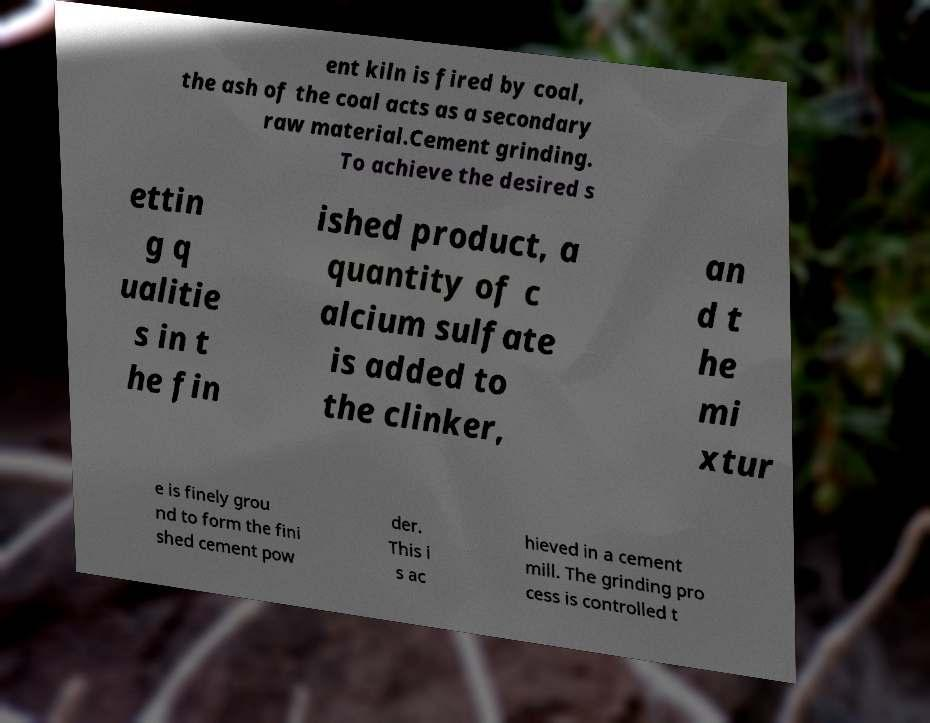Could you extract and type out the text from this image? ent kiln is fired by coal, the ash of the coal acts as a secondary raw material.Cement grinding. To achieve the desired s ettin g q ualitie s in t he fin ished product, a quantity of c alcium sulfate is added to the clinker, an d t he mi xtur e is finely grou nd to form the fini shed cement pow der. This i s ac hieved in a cement mill. The grinding pro cess is controlled t 